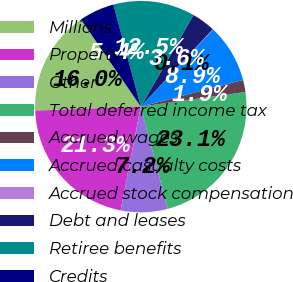<chart> <loc_0><loc_0><loc_500><loc_500><pie_chart><fcel>Millions<fcel>Property<fcel>Other<fcel>Total deferred income tax<fcel>Accrued wages<fcel>Accrued casualty costs<fcel>Accrued stock compensation<fcel>Debt and leases<fcel>Retiree benefits<fcel>Credits<nl><fcel>16.03%<fcel>21.34%<fcel>7.16%<fcel>23.12%<fcel>1.85%<fcel>8.94%<fcel>0.07%<fcel>3.62%<fcel>12.48%<fcel>5.39%<nl></chart> 